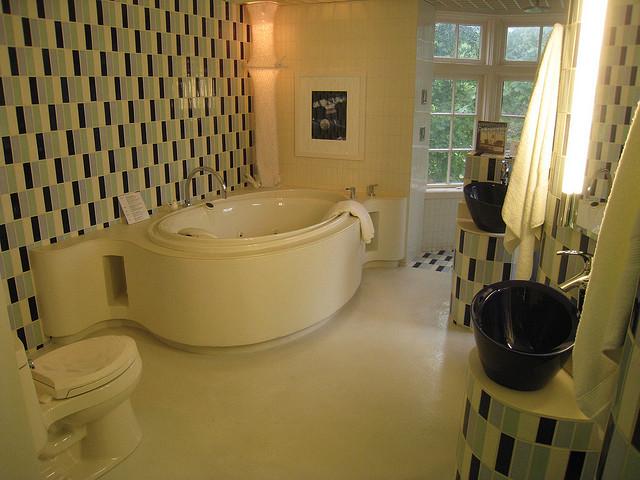Is there carpeting in this bathroom?
Concise answer only. No. How many urinals are visible?
Be succinct. 0. What is laying on the side of the tub?
Write a very short answer. Towel. What is on the counter?
Short answer required. Sink. Why is there a book on the tub?
Short answer required. To read. 